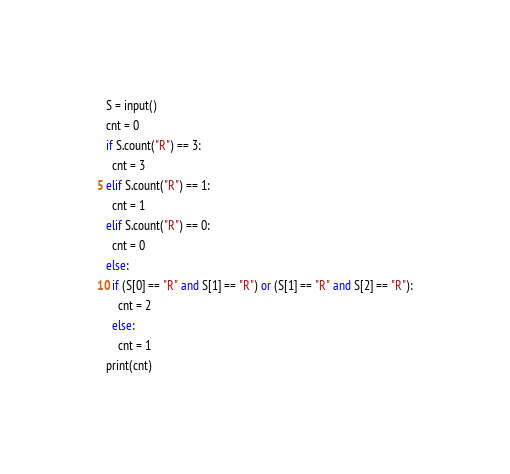Convert code to text. <code><loc_0><loc_0><loc_500><loc_500><_Python_>S = input()
cnt = 0
if S.count("R") == 3:
  cnt = 3
elif S.count("R") == 1:
  cnt = 1
elif S.count("R") == 0:
  cnt = 0
else:
  if (S[0] == "R" and S[1] == "R") or (S[1] == "R" and S[2] == "R"):
    cnt = 2
  else:
    cnt = 1
print(cnt)</code> 